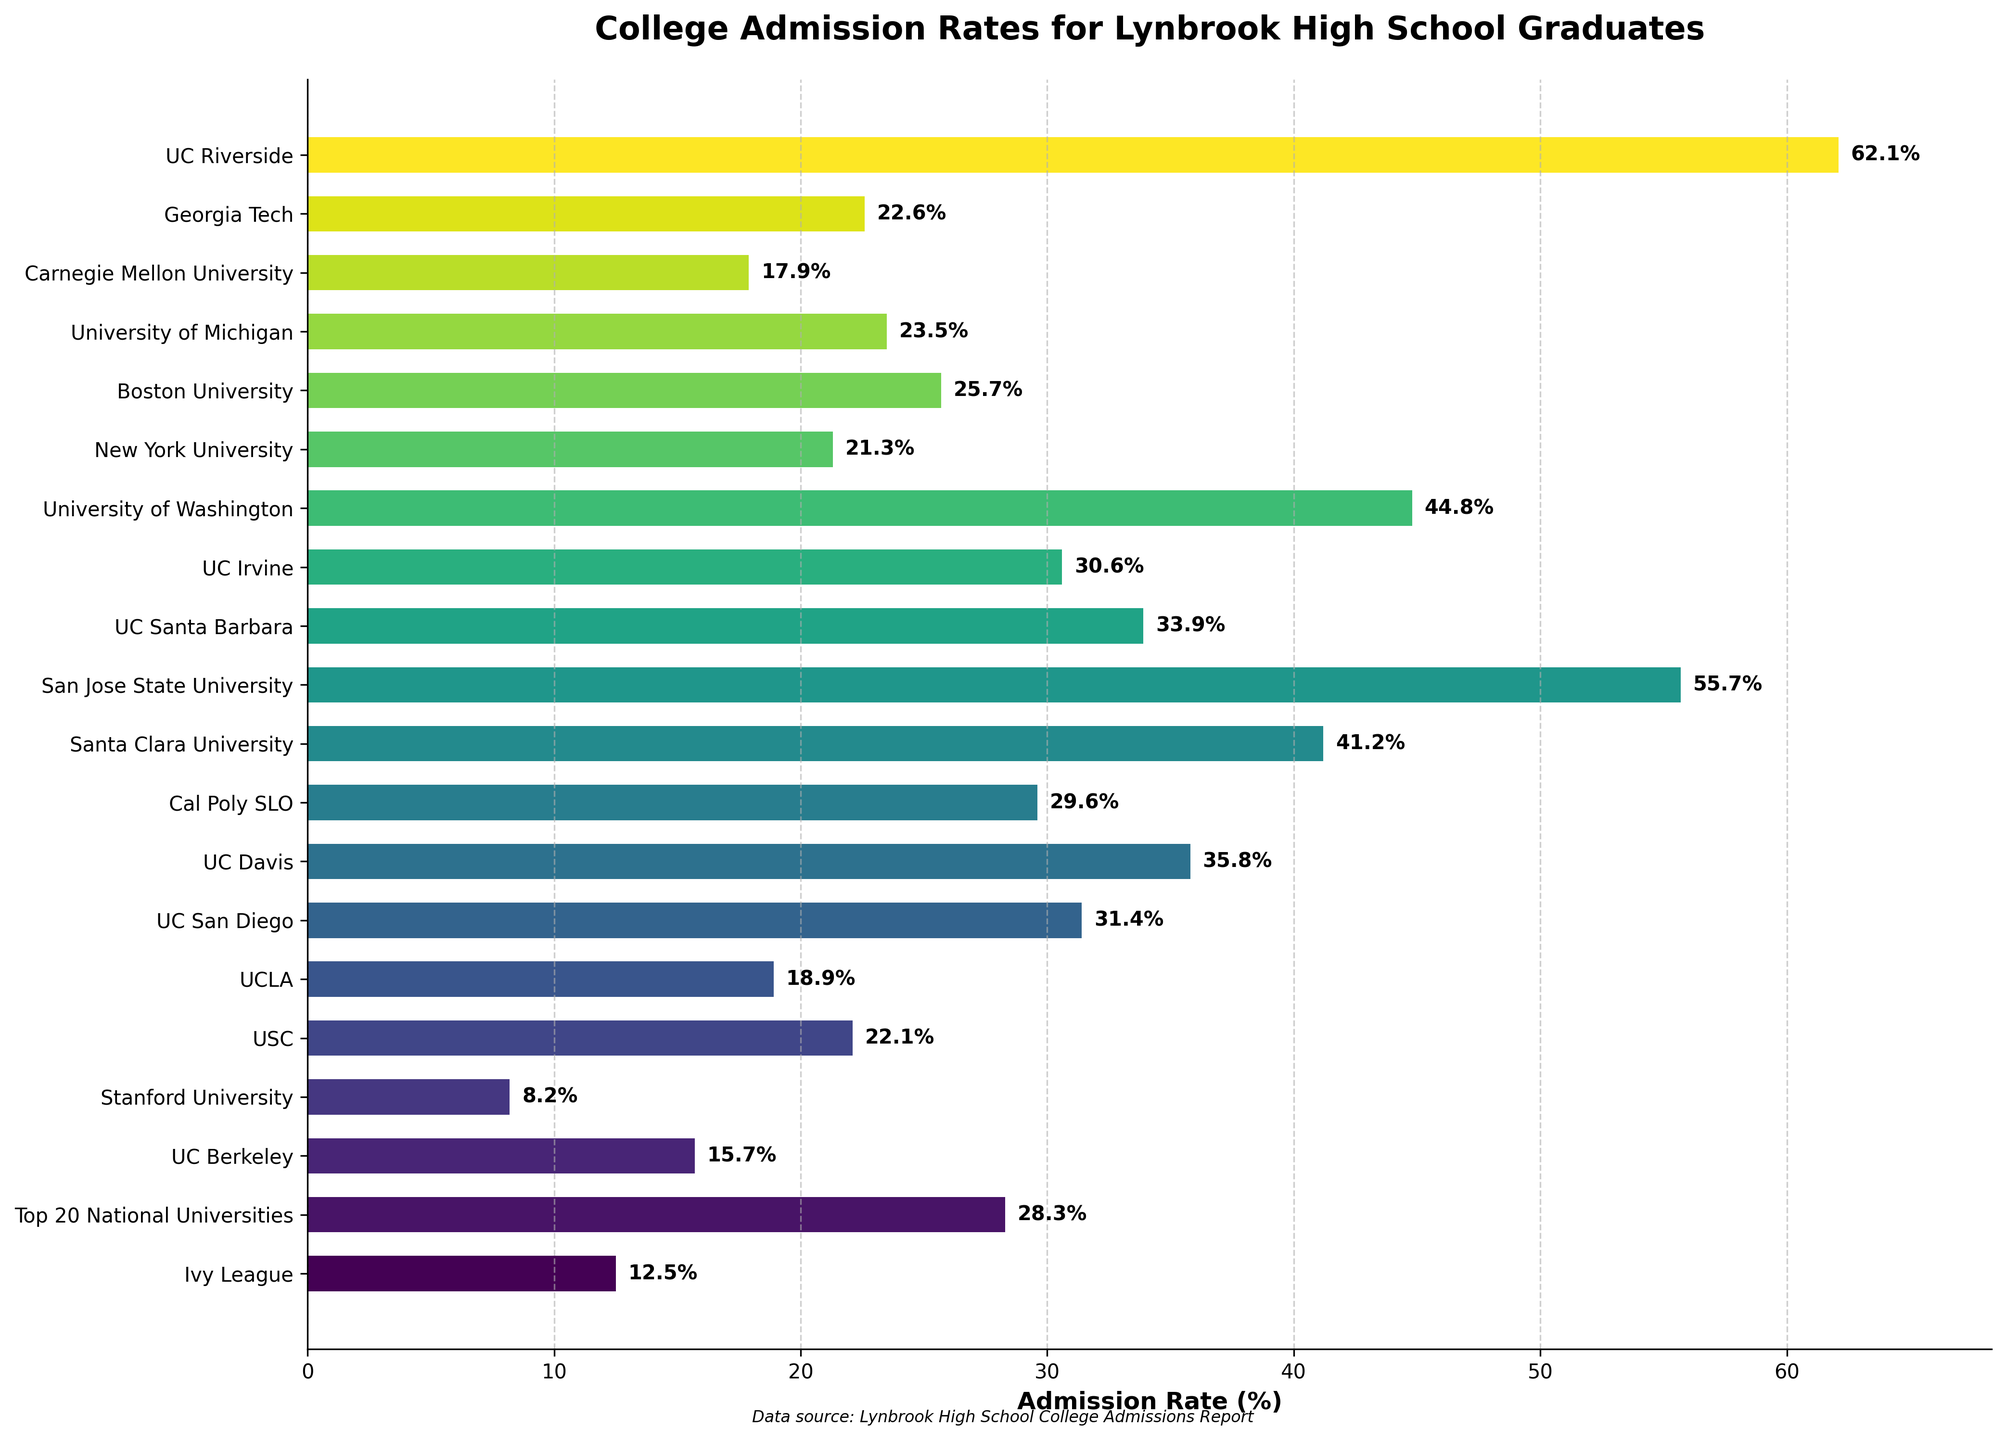Which university tier has the highest admission rate? Examine the chart and identify the bar with the longest length (indicating the highest admission rate). The University Tier with the highest admission rate has the most extended bar.
Answer: UC Riverside Which university has a lower admission rate: Stanford University or New York University? Compare the lengths of the bars for Stanford University and New York University. The bar with the smaller length represents the lower admission rate.
Answer: Stanford University What is the difference in admission rates between UC Berkeley and UC Riverside? Subtract the admission rate of UC Berkeley (15.7%) from the admission rate of UC Riverside (62.1%).
Answer: 46.4% What is the average admission rate for the University of California (UC) schools listed? Calculate the mean of the admission rates for the following UC schools: UC Berkeley (15.7%), UCLA (18.9%), UC San Diego (31.4%), UC Davis (35.8%), UC Santa Barbara (33.9%), UC Irvine (30.6%), and UC Riverside (62.1%). Add these rates and divide by the number of schools (7).
Answer: 32.06% Which universities have admission rates greater than 40%? Identify the bars that extend past the 40% mark. These universities are Santa Clara University (41.2%), San Jose State University (55.7%), UC Riverside (62.1%), and University of Washington (44.8%).
Answer: Santa Clara University, San Jose State University, UC Riverside, University of Washington Which university has the closest admission rate to 30%? Find the bar with an admission rate closest to 30%. Compare the values around 30% and identify the closest one.
Answer: UC San Diego What is the median admission rate among all the universities listed? Sort the admission rates in ascending order and find the middle value. With an odd number of data points, the median will be the middle value. With an even number of data points, it will be the average of the two middle values. In this case, there are 19 universities, so sort and choose the 10th value from the list.
Answer: 28.3% (Top 20 National Universities) 